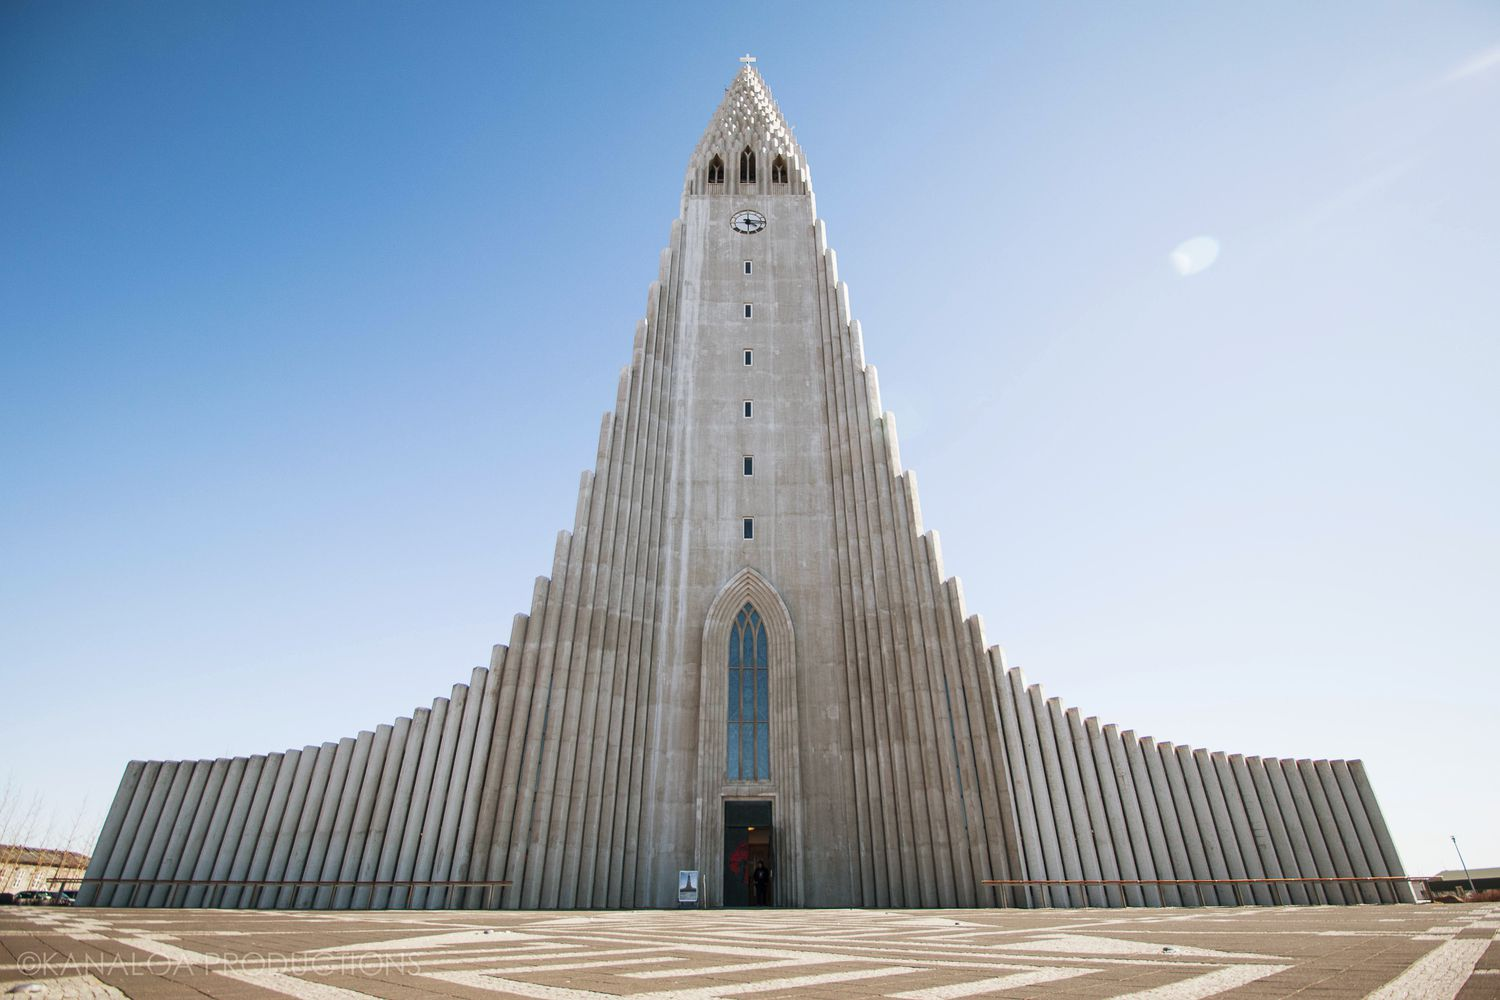If Hallgrímskirkja could speak, what stories might it tell about the people who have visited it over the years? If Hallgrímskirkja could speak, it would share stories of countless souls seeking solace, inspiration, and communion. It would recount moments of joy as newlyweds walked down its aisle, the whispered prayers of the hopeful, and the somber tones of bereavement during funerals. It would remember the enthralled audiences listening to the grand organ concerts and the curious tourists marveling at its architecture. The church might tell of the diverse range of visitors, from local parishioners to international explorers, all finding a moment of peace and reflection within its walls. It would reflect on the many seasons it has witnessed, from the bright, long days of summer to the serene and silent snow-covered winters, creating a timeless narrative of faith, community, and human experience. 